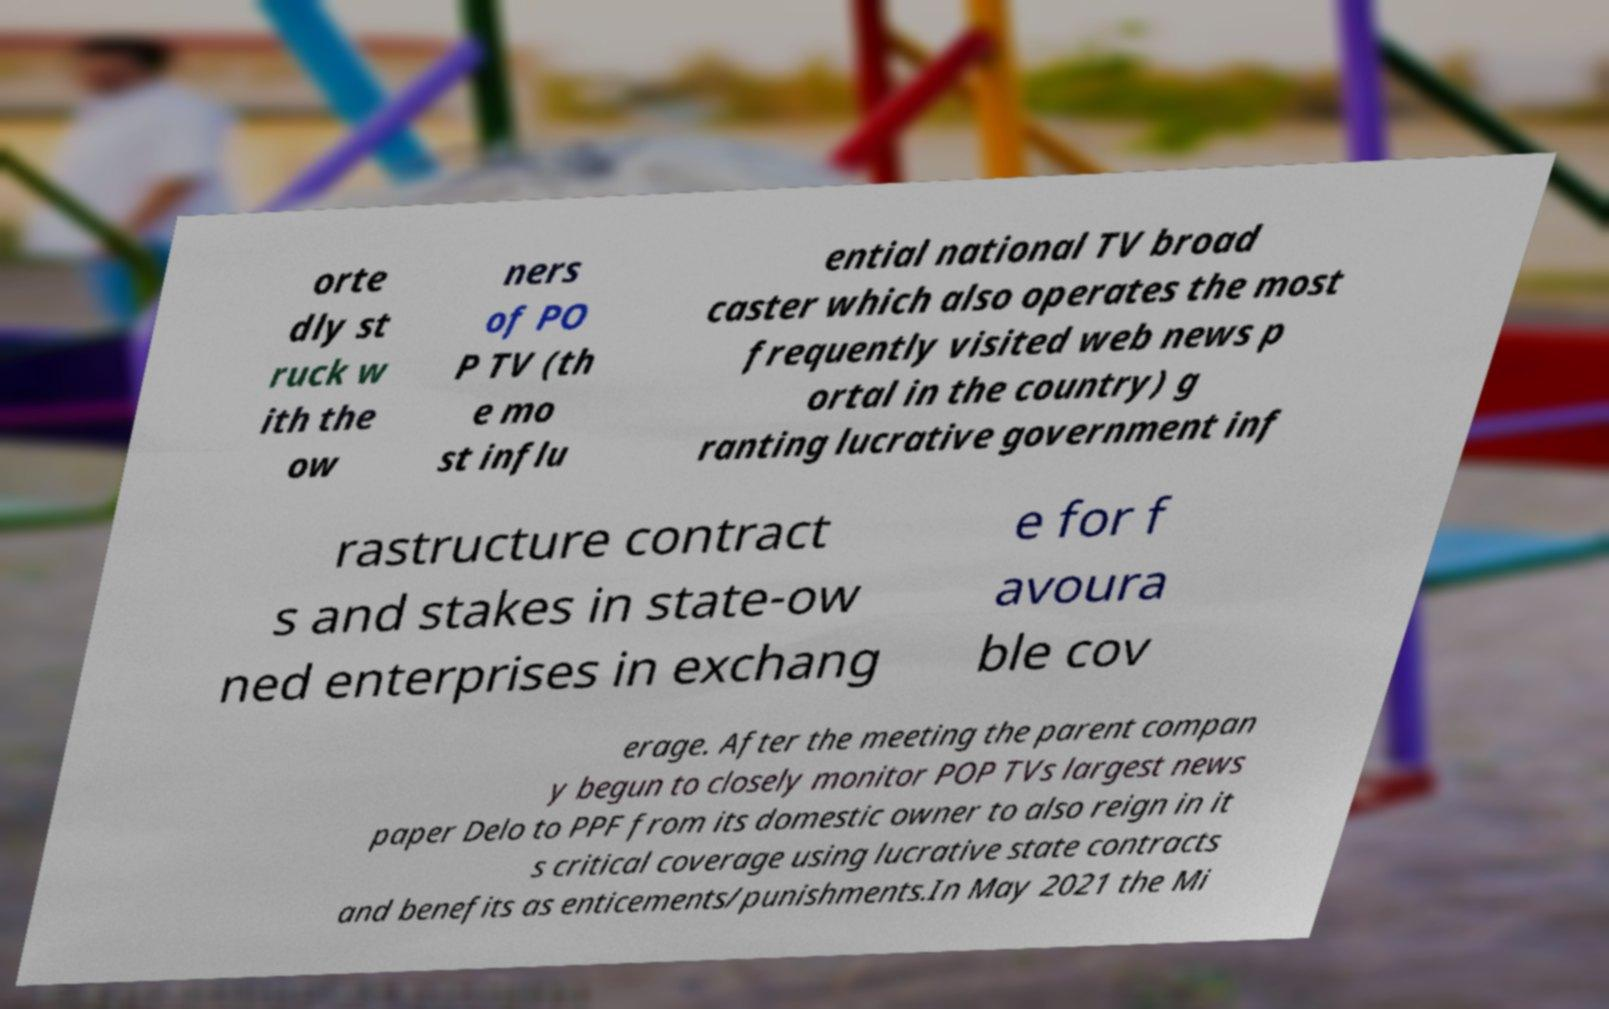Can you accurately transcribe the text from the provided image for me? orte dly st ruck w ith the ow ners of PO P TV (th e mo st influ ential national TV broad caster which also operates the most frequently visited web news p ortal in the country) g ranting lucrative government inf rastructure contract s and stakes in state-ow ned enterprises in exchang e for f avoura ble cov erage. After the meeting the parent compan y begun to closely monitor POP TVs largest news paper Delo to PPF from its domestic owner to also reign in it s critical coverage using lucrative state contracts and benefits as enticements/punishments.In May 2021 the Mi 